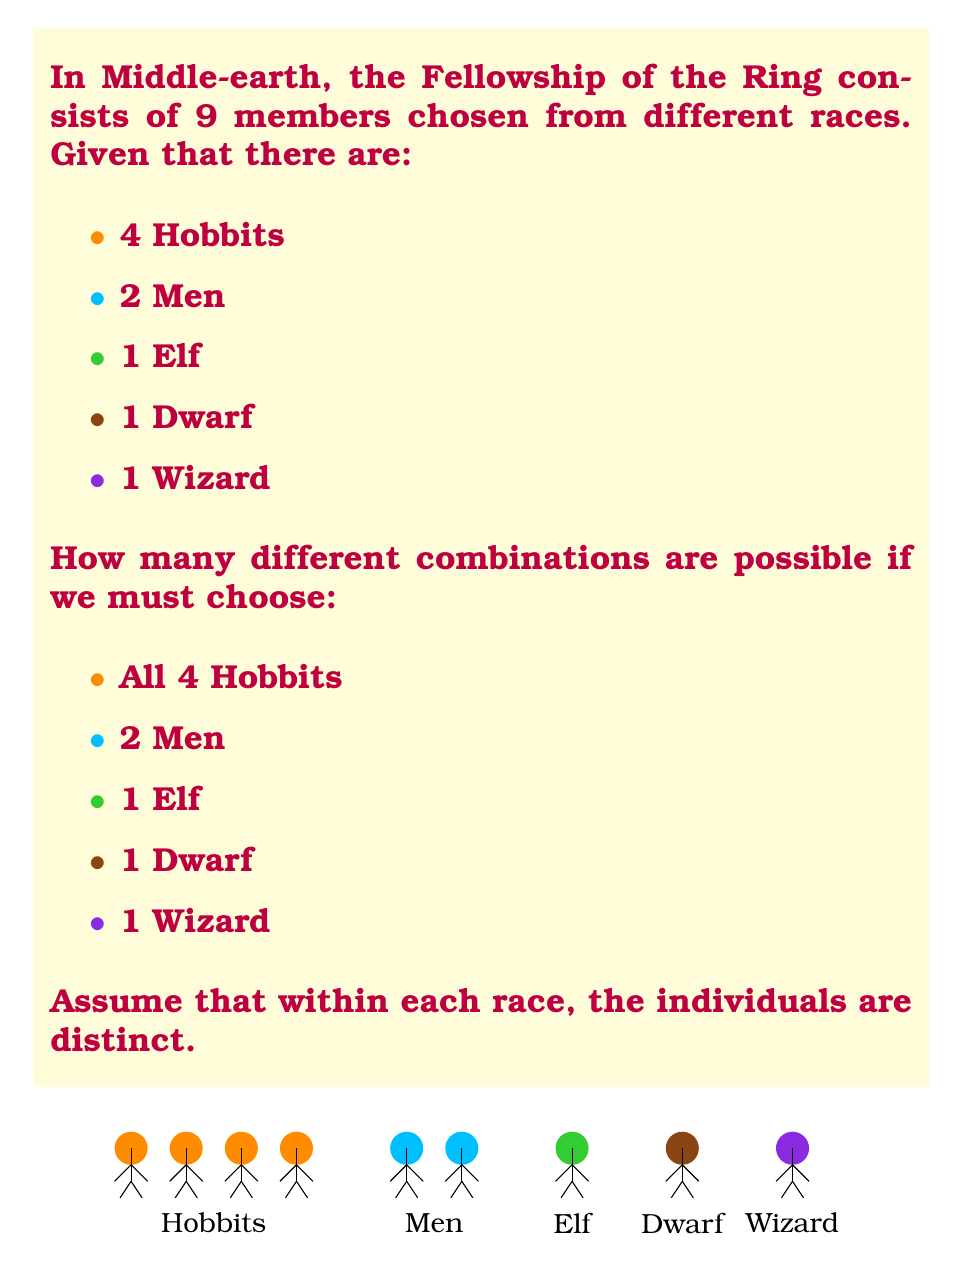Help me with this question. Let's approach this step-by-step using the multiplication principle of counting:

1) For the Hobbits:
   We must choose all 4 Hobbits, so there's only 1 way to do this.
   $n_1 = 1$

2) For the Men:
   We need to choose 2 out of 2 Men. This can be done in only 1 way.
   $n_2 = 1$

3) For the Elf:
   There's only 1 Elf, and we must choose him. So again, only 1 way.
   $n_3 = 1$

4) For the Dwarf:
   Similarly, there's only 1 Dwarf, and we must choose him. So 1 way.
   $n_4 = 1$

5) For the Wizard:
   There's only 1 Wizard, and we must choose him. So 1 way.
   $n_5 = 1$

Now, according to the multiplication principle, if we have a sequence of $k$ choices, and the $i$-th choice can be made in $n_i$ ways (regardless of how the other choices are made), then the total number of ways to make all $k$ choices is:

$$ N = n_1 \times n_2 \times n_3 \times ... \times n_k $$

In our case:

$$ N = 1 \times 1 \times 1 \times 1 \times 1 = 1 $$

Therefore, there is only 1 possible combination for forming the Fellowship of the Ring under these constraints.
Answer: 1 